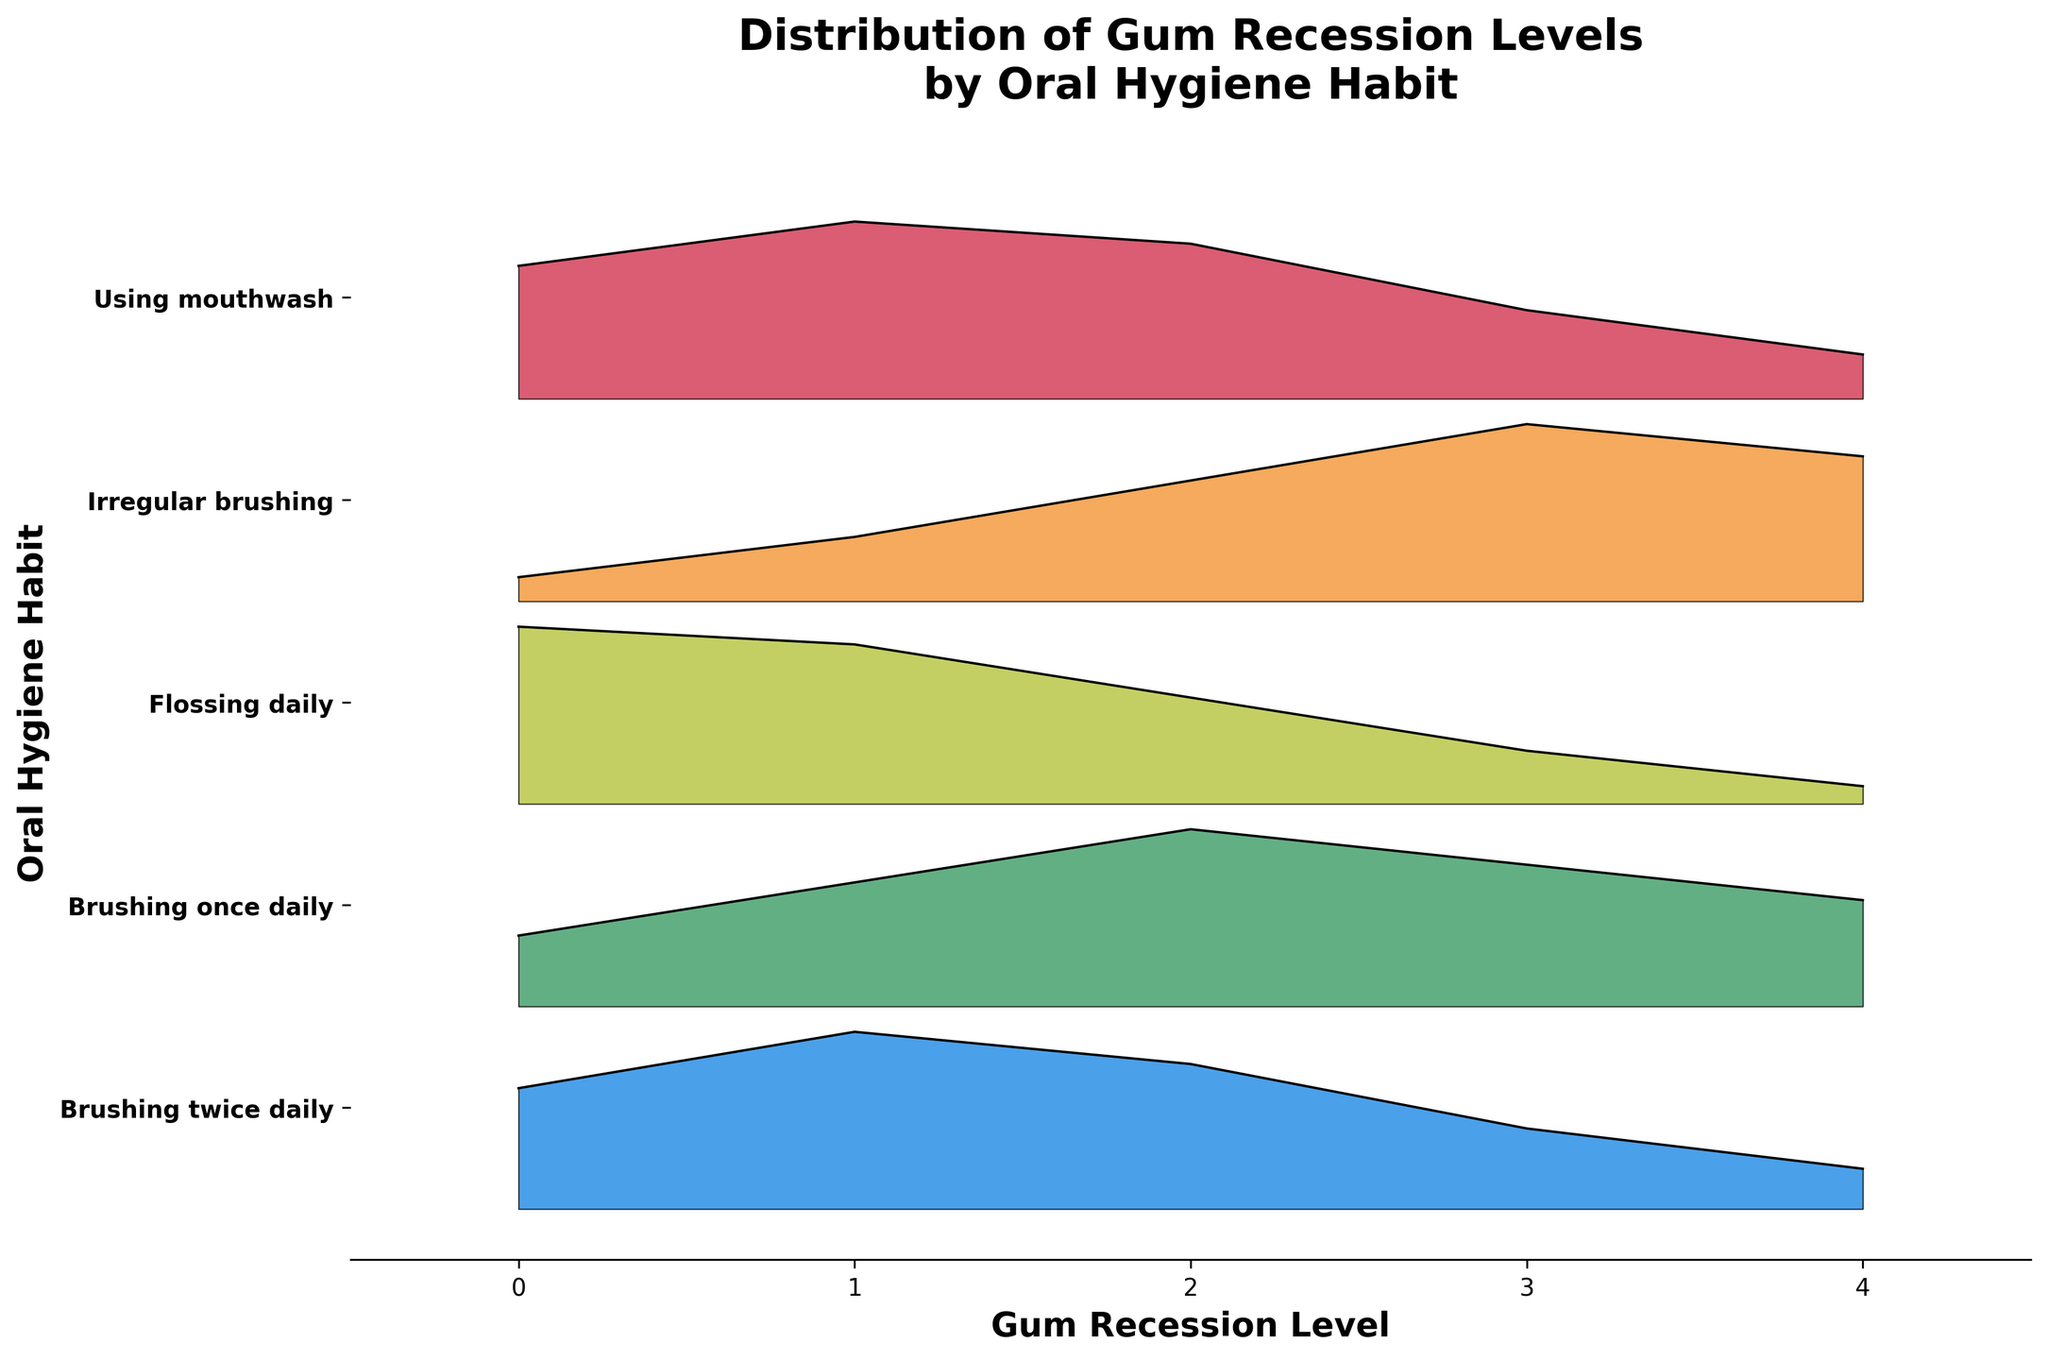What is the title of the figure? The title is located at the top of the figure, typically in a larger and bold font. It provides a summary of what the figure represents.
Answer: Distribution of Gum Recession Levels by Oral Hygiene Habit Which oral hygiene habit has the highest frequency for the gum recession level of 0? Check the ridgeline plot for the gum recession level of 0 across different habits and identify the one with the highest peak on its respective line.
Answer: Flossing daily How many oral hygiene habits are shown in the figure? Count the number of unique labels on the y-axis, each representing a different oral hygiene habit.
Answer: 5 Which habit has a higher frequency of severe gum recession levels (3 and 4) compared to light gum recession levels (0 and 1)? Compare the frequencies of gum recession levels 3 and 4 versus 0 and 1 for each habit. The habit with the higher sum for severe levels compared to light levels is the answer.
Answer: Irregular brushing How does the distribution of gum recession levels for "Brushing twice daily" compare to "Brushing once daily"? Compare the shapes, frequencies, and heights of the distributions for both habits across all gum recession levels. "Brushing twice daily" generally has lower frequencies for higher recession levels compared to "Brushing once daily".
Answer: "Brushing once daily" shows higher frequencies for higher recession levels What is the most frequent gum recession level when using mouthwash? Identify the peak of the line corresponding to "Using mouthwash" to find the gum recession level with the highest frequency.
Answer: 1 What is the oral hygiene habit with the lowest frequency for gum recession level 2? Compare the heights of the frequency values for gum recession level 2 across all habits and identify the lowest one.
Answer: Flossing daily Which habit indicates the most balanced distribution across all gum recession levels? Look for the habit where the frequencies are the most evenly distributed without sharp peaks or troughs across all levels.
Answer: Using mouthwash What can you infer about the effectiveness of flossing based on the gum recession levels? Examine the frequency distribution for "Flossing daily" across all gum recession levels. Note the higher frequencies for low recession levels and lower frequencies for higher recession levels.
Answer: Flossing daily seems effective in preventing severe gum recession 